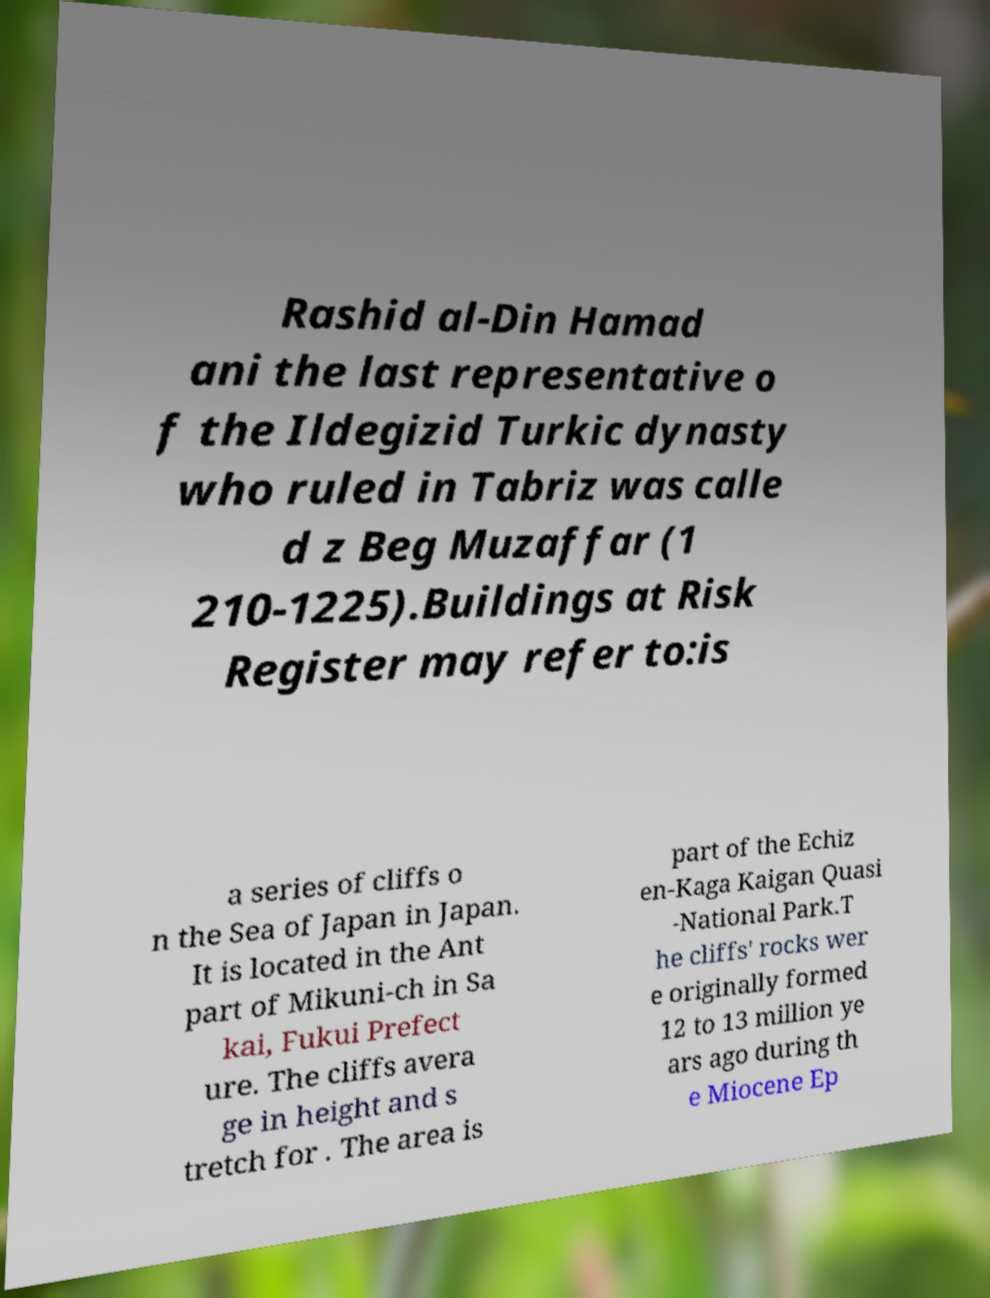There's text embedded in this image that I need extracted. Can you transcribe it verbatim? Rashid al-Din Hamad ani the last representative o f the Ildegizid Turkic dynasty who ruled in Tabriz was calle d z Beg Muzaffar (1 210-1225).Buildings at Risk Register may refer to:is a series of cliffs o n the Sea of Japan in Japan. It is located in the Ant part of Mikuni-ch in Sa kai, Fukui Prefect ure. The cliffs avera ge in height and s tretch for . The area is part of the Echiz en-Kaga Kaigan Quasi -National Park.T he cliffs' rocks wer e originally formed 12 to 13 million ye ars ago during th e Miocene Ep 